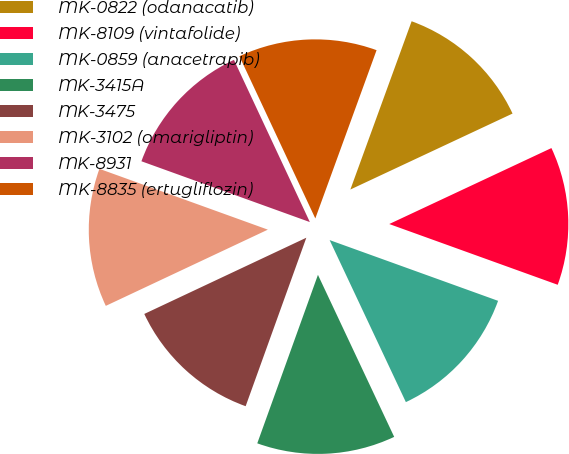Convert chart. <chart><loc_0><loc_0><loc_500><loc_500><pie_chart><fcel>MK-0822 (odanacatib)<fcel>MK-8109 (vintafolide)<fcel>MK-0859 (anacetrapib)<fcel>MK-3415A<fcel>MK-3475<fcel>MK-3102 (omarigliptin)<fcel>MK-8931<fcel>MK-8835 (ertugliflozin)<nl><fcel>12.47%<fcel>12.48%<fcel>12.49%<fcel>12.5%<fcel>12.5%<fcel>12.51%<fcel>12.52%<fcel>12.52%<nl></chart> 